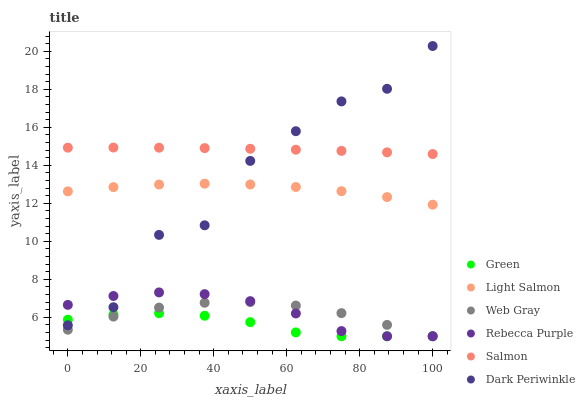Does Green have the minimum area under the curve?
Answer yes or no. Yes. Does Salmon have the maximum area under the curve?
Answer yes or no. Yes. Does Web Gray have the minimum area under the curve?
Answer yes or no. No. Does Web Gray have the maximum area under the curve?
Answer yes or no. No. Is Salmon the smoothest?
Answer yes or no. Yes. Is Dark Periwinkle the roughest?
Answer yes or no. Yes. Is Web Gray the smoothest?
Answer yes or no. No. Is Web Gray the roughest?
Answer yes or no. No. Does Web Gray have the lowest value?
Answer yes or no. Yes. Does Salmon have the lowest value?
Answer yes or no. No. Does Dark Periwinkle have the highest value?
Answer yes or no. Yes. Does Web Gray have the highest value?
Answer yes or no. No. Is Light Salmon less than Salmon?
Answer yes or no. Yes. Is Salmon greater than Web Gray?
Answer yes or no. Yes. Does Dark Periwinkle intersect Salmon?
Answer yes or no. Yes. Is Dark Periwinkle less than Salmon?
Answer yes or no. No. Is Dark Periwinkle greater than Salmon?
Answer yes or no. No. Does Light Salmon intersect Salmon?
Answer yes or no. No. 